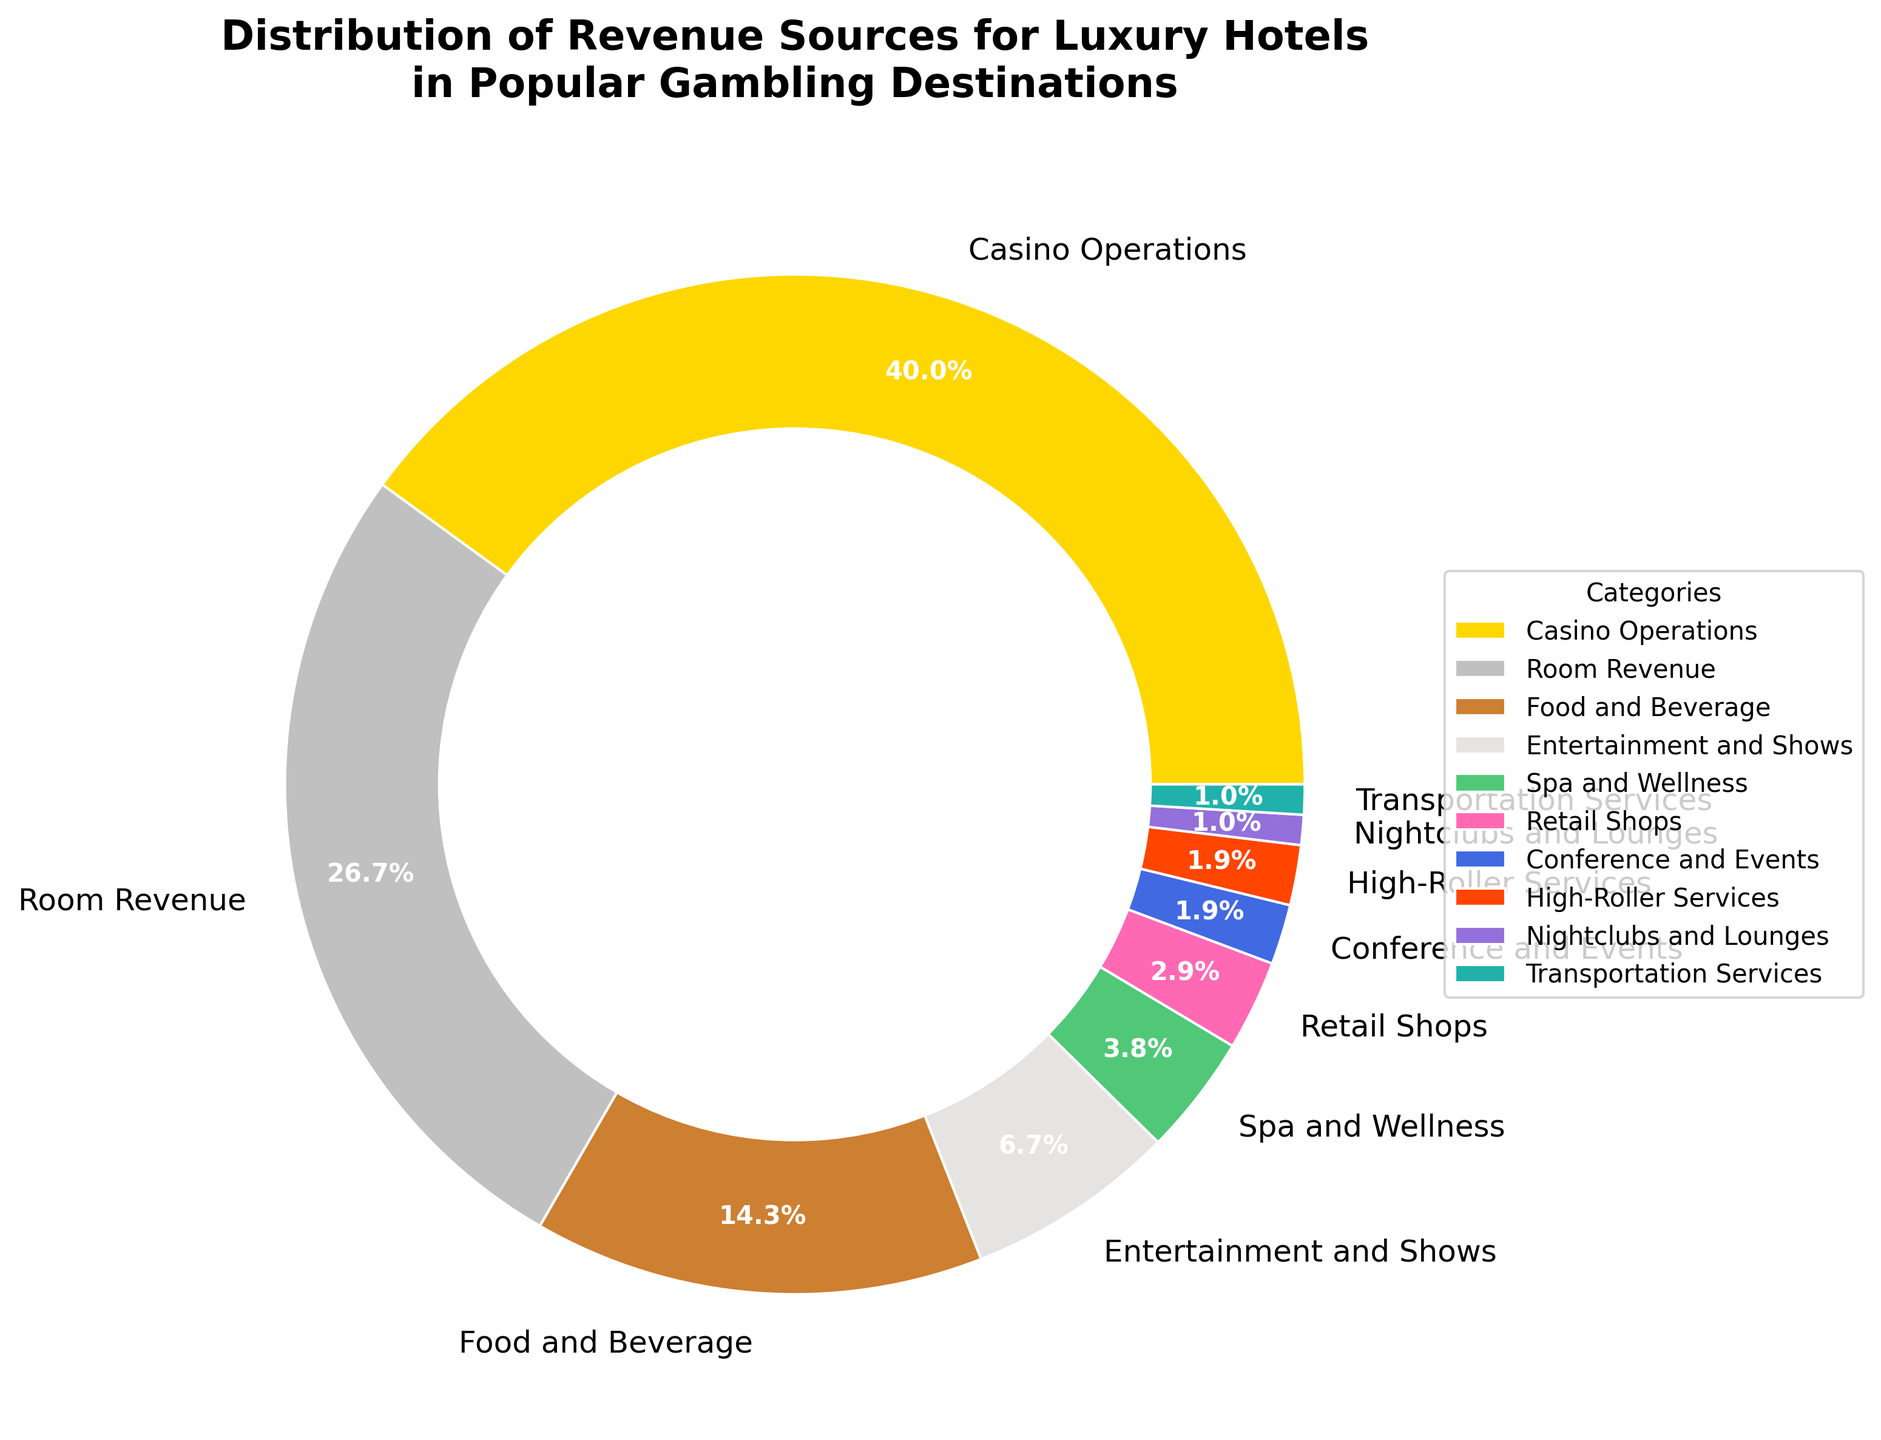What is the largest revenue source for luxury hotels in popular gambling destinations? The largest revenue source can be identified by looking for the category with the biggest slice of the pie chart. In this case, the category labeled "Casino Operations" occupies the largest portion.
Answer: Casino Operations What percentage of revenue comes from Room Revenue and Food and Beverage combined? First, find the percentages for Room Revenue and Food and Beverage from the chart, which are 28% and 15%, respectively. Then add these values: 28% + 15% = 43%.
Answer: 43% Which revenue source contributes the least to the total revenue? The smallest slice of the pie chart represents the category contributing the least. This is the "Nightclubs and Lounges" category with a 1% share.
Answer: Nightclubs and Lounges Are Spa and Wellness or Retail Shops a larger revenue source, and by how much? Compare the percentages for Spa and Wellness (4%) and Retail Shops (3%). The difference is found by subtracting the smaller percentage from the larger one: 4% - 3% = 1%.
Answer: Spa and Wellness by 1% What portion of the revenue comes from non-entertainment sources (excluding Casino Operations, Entertainment and Shows, Nightclubs and Lounges)? Add the percentages of Room Revenue (28%), Food and Beverage (15%), Spa and Wellness (4%), Retail Shops (3%), Conference and Events (2%), High-Roller Services (2%), and Transportation Services (1%). This equals 55%.
Answer: 55% How does the combined revenue of Conference and Events, High-Roller Services, and Nightclubs and Lounges compare to Transportation Services? Add the percentages for Conference and Events (2%), High-Roller Services (2%), and Nightclubs and Lounges (1%) to get a total of 5%, compared to Transportation Services which contributes 1%.
Answer: 5% to 1% Which three categories contribute equally to the revenue? Identify the categories with the same percentage. Here, Conference and Events, High-Roller Services, and Transportation Services each contribute 2%.
Answer: Conference and Events, High-Roller Services, Transportation Services 